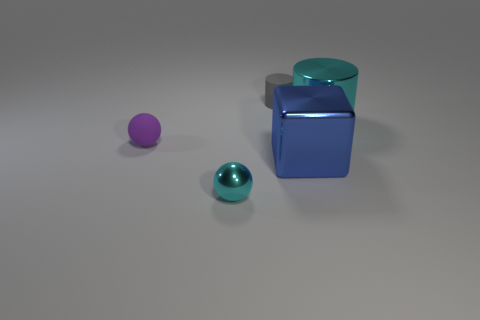Is there any other thing that has the same shape as the large blue metallic thing?
Your answer should be very brief. No. How many things are purple matte things that are behind the large blue metallic thing or small brown metal cylinders?
Your answer should be very brief. 1. Do the small cyan object and the tiny gray rubber object have the same shape?
Ensure brevity in your answer.  No. What number of other things are there of the same size as the shiny block?
Your answer should be very brief. 1. The matte sphere has what color?
Your answer should be compact. Purple. What number of small things are shiny objects or cyan rubber things?
Your answer should be compact. 1. There is a metallic thing right of the blue shiny block; does it have the same size as the matte object that is to the left of the tiny metal object?
Make the answer very short. No. What is the size of the gray thing that is the same shape as the large cyan object?
Keep it short and to the point. Small. Is the number of small cyan metallic balls that are right of the purple matte ball greater than the number of large metal cubes that are behind the gray cylinder?
Offer a very short reply. Yes. What is the thing that is both left of the blue object and behind the purple thing made of?
Give a very brief answer. Rubber. 